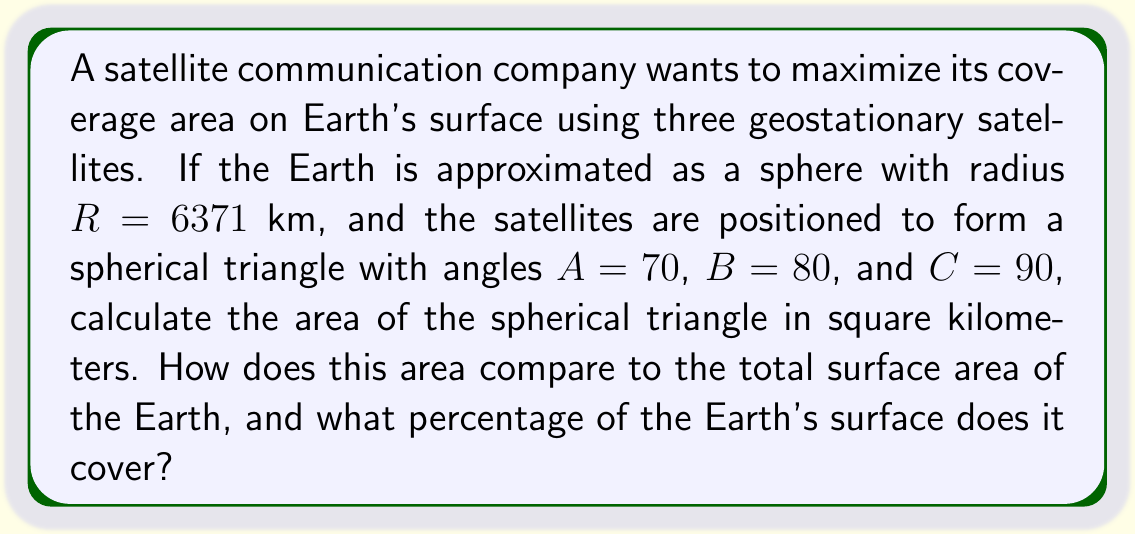Can you solve this math problem? To solve this problem and maximize profit through efficient satellite coverage, we'll follow these steps:

1) The area of a spherical triangle is given by the formula:

   $$A = R^2(A + B + C - \pi)$$

   Where $R$ is the radius of the sphere, and $A$, $B$, and $C$ are the angles of the spherical triangle in radians.

2) Convert the given angles from degrees to radians:

   $A = 70° = \frac{70\pi}{180} \approx 1.2217$ radians
   $B = 80° = \frac{80\pi}{180} \approx 1.3963$ radians
   $C = 90° = \frac{90\pi}{180} = \frac{\pi}{2} \approx 1.5708$ radians

3) Substitute these values into the formula:

   $$A = (6371)^2(1.2217 + 1.3963 + 1.5708 - \pi)$$
   $$A = 40589641(4.1888 - \pi)$$
   $$A = 40589641(1.0472)$$
   $$A \approx 42506537.67 \text{ km}^2$$

4) To calculate the percentage of Earth's surface covered, we need the total surface area of the Earth:

   $$S_{\text{Earth}} = 4\pi R^2 = 4\pi(6371)^2 \approx 510064471.9 \text{ km}^2$$

5) Calculate the percentage:

   $$\text{Percentage} = \frac{A}{S_{\text{Earth}}} \times 100\% = \frac{42506537.67}{510064471.9} \times 100\% \approx 8.33\%$$
Answer: 42506537.67 km²; 8.33% of Earth's surface 